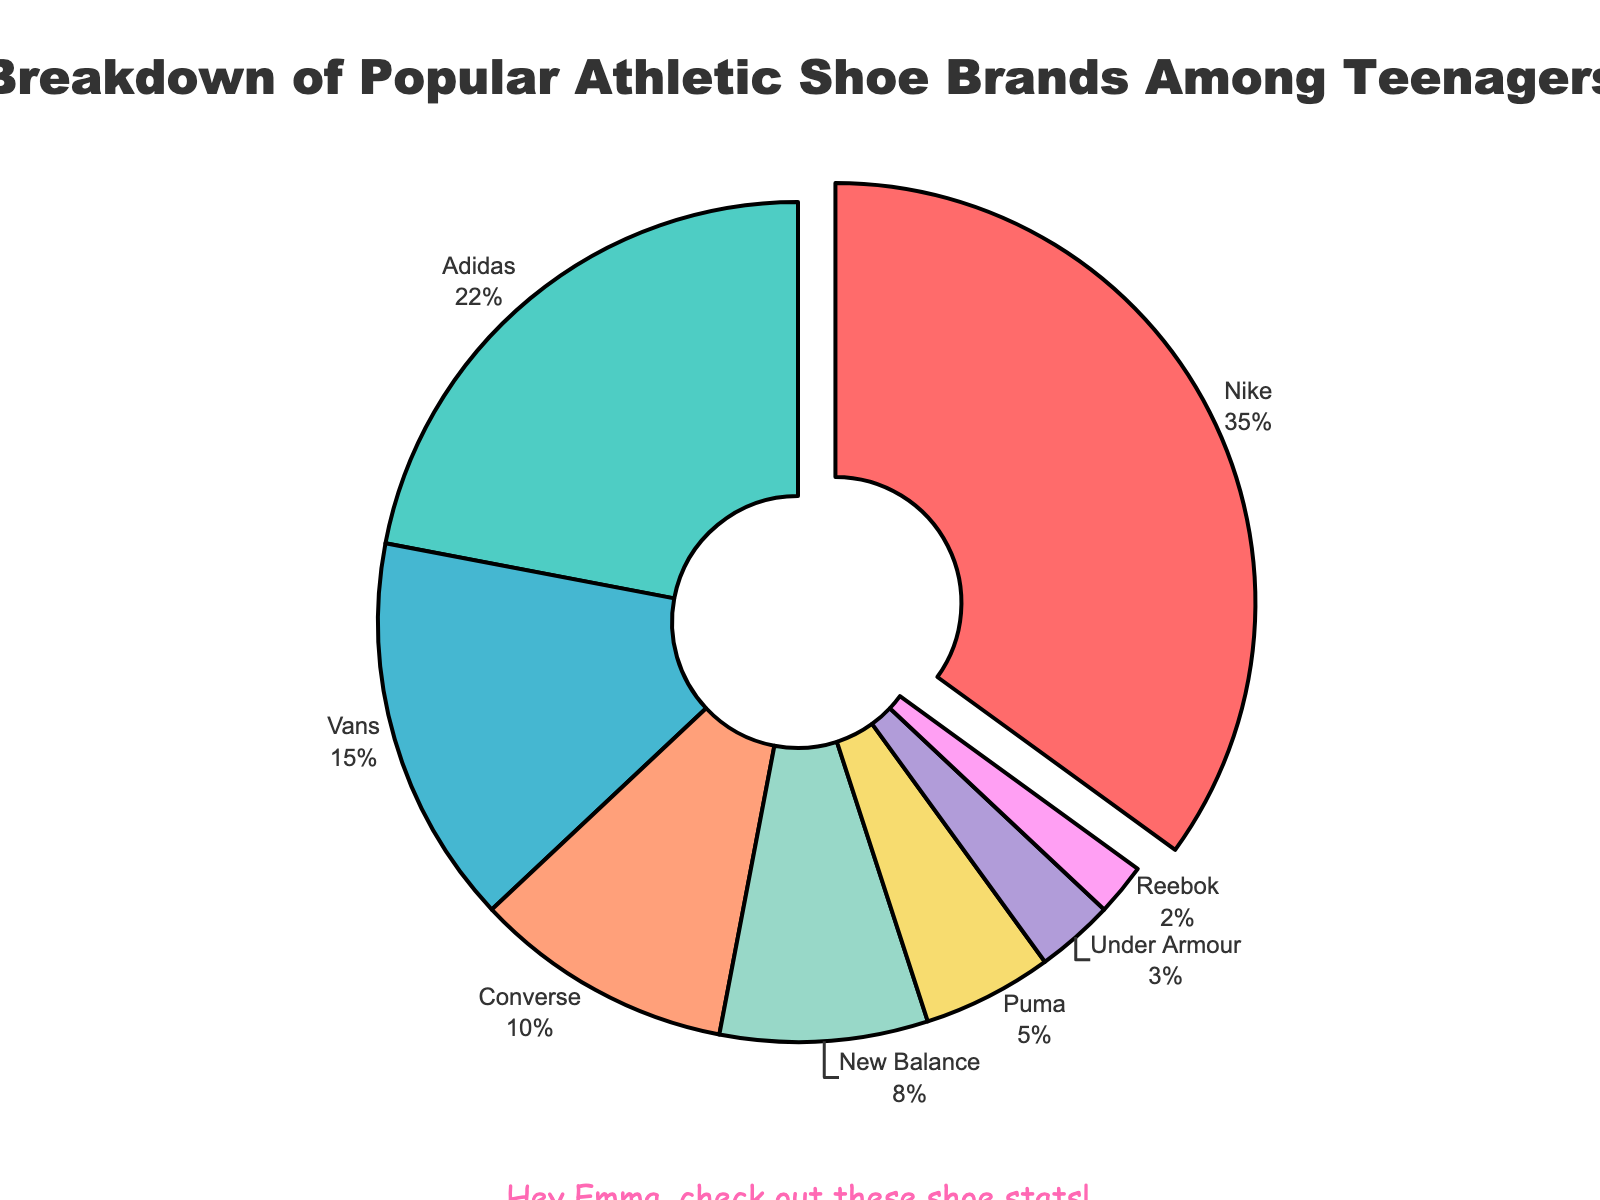Which brand is the most popular among teenagers? To find the most popular brand, look for the brand with the highest percentage. Nike has 35%, which is the highest.
Answer: Nike How much more popular is Nike compared to Adidas? Nike has 35% while Adidas has 22%. Subtract the percentage of Adidas from Nike's: 35% - 22% = 13%.
Answer: 13% What is the total percentage of the three least popular brands? The three least popular brands are Reebok (2%), Under Armour (3%), and Puma (5%). Sum their percentages: 2% + 3% + 5% = 10%.
Answer: 10% Which brand has the smallest share among teenagers? To determine the brand with the smallest share, look for the brand with the smallest percentage. Reebok has 2%, which is the smallest.
Answer: Reebok What is the combined percentage of Vans and Converse? Vans has 15% and Converse has 10%. Add their percentages: 15% + 10% = 25%.
Answer: 25% Is New Balance more or less popular than Vans? To compare their popularity, look at their percentages. New Balance has 8% and Vans has 15%. Since 8% is less than 15%, New Balance is less popular.
Answer: Less What percentage of teenagers prefer brands other than Nike and Adidas? Exclude Nike (35%) and Adidas (22%) from the total (100%). Subtract their combined percentage from 100%: 100% - (35% + 22%) = 43%.
Answer: 43% Between Puma and Under Armour, which brand has a higher popularity? Compare their percentages: Puma has 5% and Under Armour has 3%. Since 5% is greater than 3%, Puma is more popular.
Answer: Puma If you combine the popularity of Converse and Reebok, is it higher than New Balance? Add the percentages of Converse (10%) and Reebok (2%): 10% + 2% = 12%. Compare with New Balance's 8%. Since 12% is greater than 8%, Converse and Reebok combined are more popular than New Balance.
Answer: Yes Which color is used to represent Adidas on the pie chart? Identify the slice corresponding to Adidas (22%). The corresponding color is teal.
Answer: Teal 